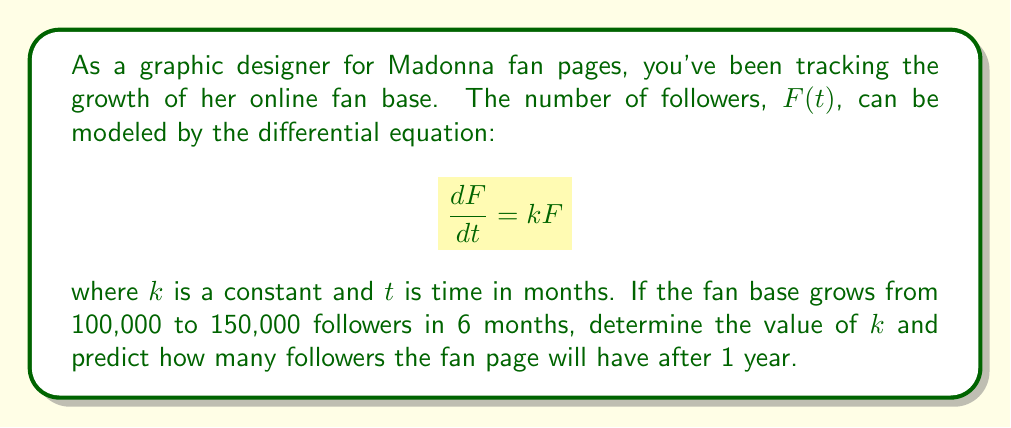Could you help me with this problem? To solve this problem, we'll follow these steps:

1) The given differential equation represents exponential growth. Its solution is:

   $$F(t) = F_0e^{kt}$$

   where $F_0$ is the initial number of followers.

2) We know that:
   - $F_0 = 100,000$ (initial followers)
   - $F(6) = 150,000$ (followers after 6 months)

3) Let's substitute these into our equation:

   $$150,000 = 100,000e^{6k}$$

4) Divide both sides by 100,000:

   $$1.5 = e^{6k}$$

5) Take the natural log of both sides:

   $$\ln(1.5) = 6k$$

6) Solve for $k$:

   $$k = \frac{\ln(1.5)}{6} \approx 0.0675$$

7) Now that we have $k$, we can predict the number of followers after 1 year (12 months):

   $$F(12) = 100,000e^{12 \cdot 0.0675}$$

8) Calculate this value:

   $$F(12) = 100,000e^{0.81} \approx 224,791$$
Answer: The growth rate constant $k$ is approximately 0.0675 per month. After 1 year, the fan page is predicted to have approximately 224,791 followers. 